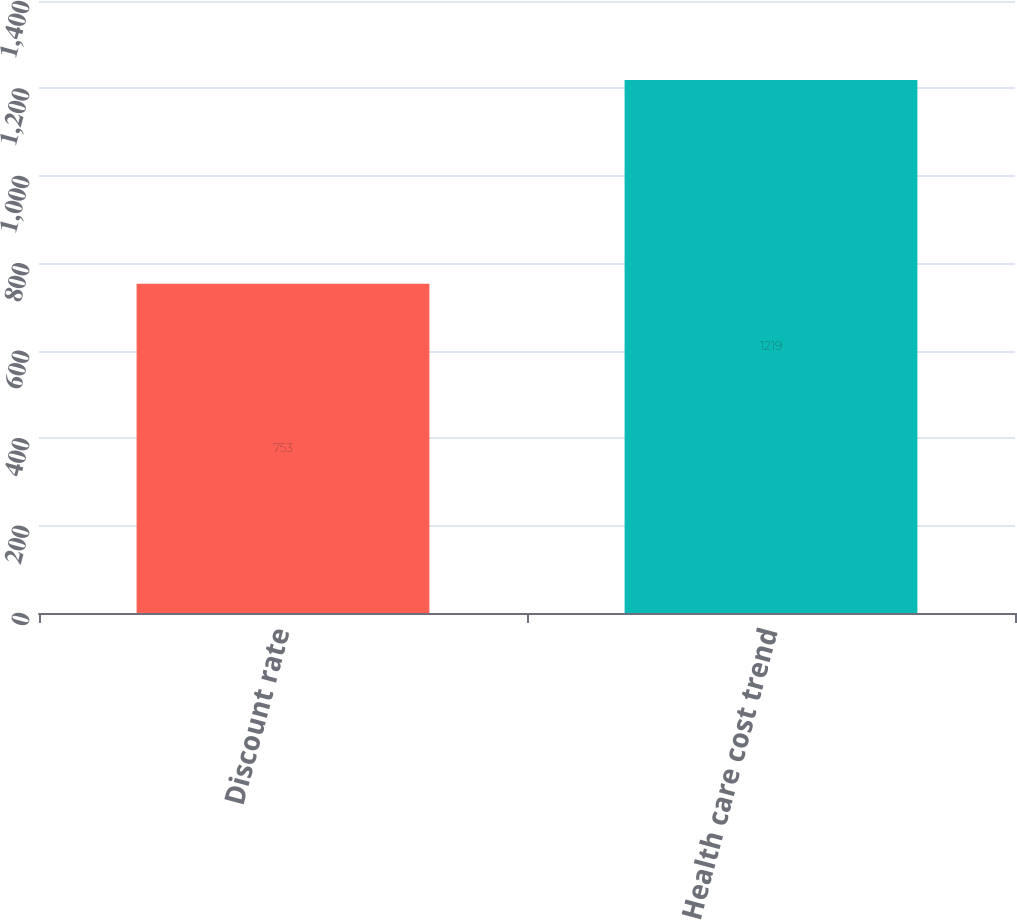Convert chart to OTSL. <chart><loc_0><loc_0><loc_500><loc_500><bar_chart><fcel>Discount rate<fcel>Health care cost trend<nl><fcel>753<fcel>1219<nl></chart> 